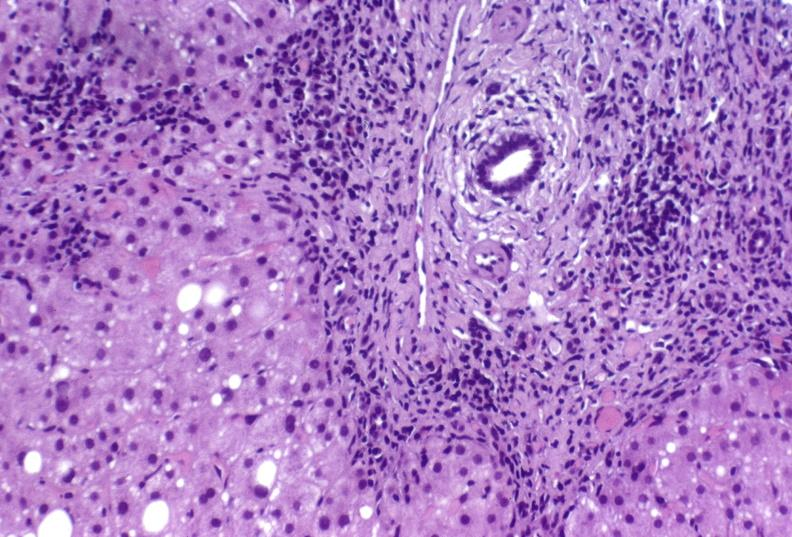does villous adenoma show hepatitis c virus?
Answer the question using a single word or phrase. No 